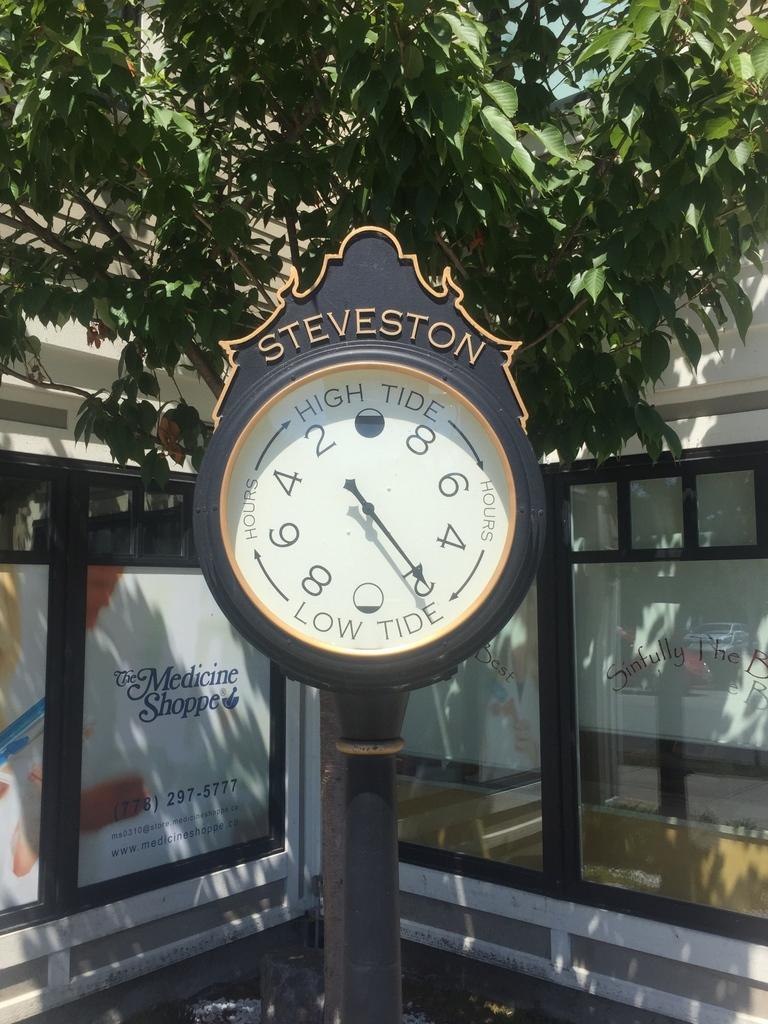What is the brand of the clock?
Provide a short and direct response. Steveston. What time does the clock say?
Make the answer very short. Unanswerable. 